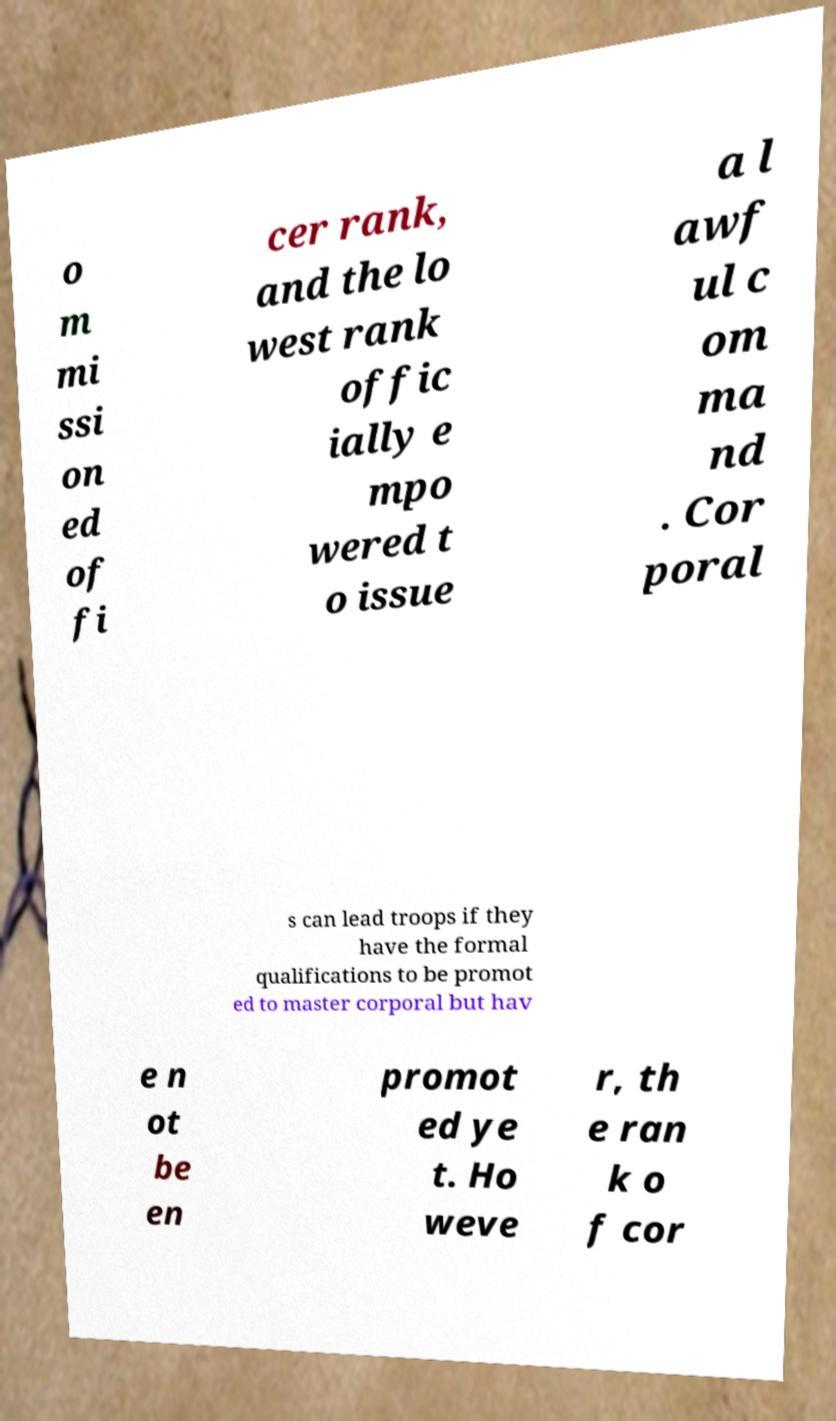Can you accurately transcribe the text from the provided image for me? o m mi ssi on ed of fi cer rank, and the lo west rank offic ially e mpo wered t o issue a l awf ul c om ma nd . Cor poral s can lead troops if they have the formal qualifications to be promot ed to master corporal but hav e n ot be en promot ed ye t. Ho weve r, th e ran k o f cor 